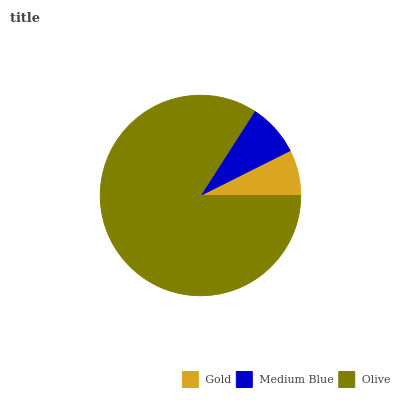Is Gold the minimum?
Answer yes or no. Yes. Is Olive the maximum?
Answer yes or no. Yes. Is Medium Blue the minimum?
Answer yes or no. No. Is Medium Blue the maximum?
Answer yes or no. No. Is Medium Blue greater than Gold?
Answer yes or no. Yes. Is Gold less than Medium Blue?
Answer yes or no. Yes. Is Gold greater than Medium Blue?
Answer yes or no. No. Is Medium Blue less than Gold?
Answer yes or no. No. Is Medium Blue the high median?
Answer yes or no. Yes. Is Medium Blue the low median?
Answer yes or no. Yes. Is Gold the high median?
Answer yes or no. No. Is Olive the low median?
Answer yes or no. No. 